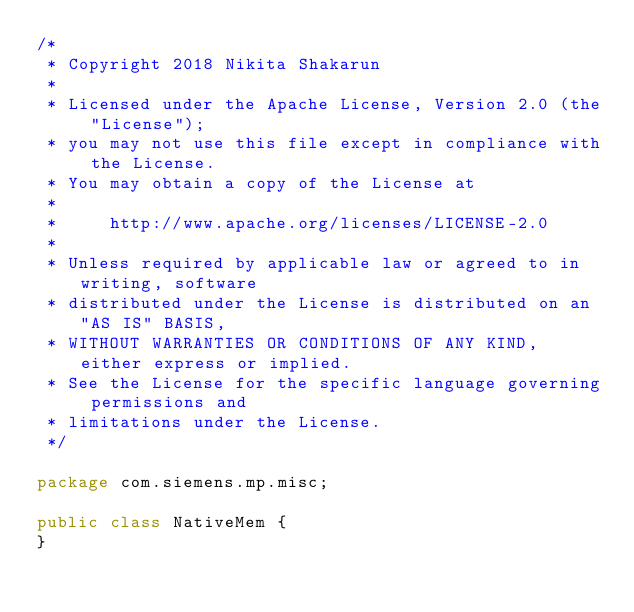<code> <loc_0><loc_0><loc_500><loc_500><_Java_>/*
 * Copyright 2018 Nikita Shakarun
 *
 * Licensed under the Apache License, Version 2.0 (the "License");
 * you may not use this file except in compliance with the License.
 * You may obtain a copy of the License at
 *
 *     http://www.apache.org/licenses/LICENSE-2.0
 *
 * Unless required by applicable law or agreed to in writing, software
 * distributed under the License is distributed on an "AS IS" BASIS,
 * WITHOUT WARRANTIES OR CONDITIONS OF ANY KIND, either express or implied.
 * See the License for the specific language governing permissions and
 * limitations under the License.
 */

package com.siemens.mp.misc;

public class NativeMem {
}
</code> 